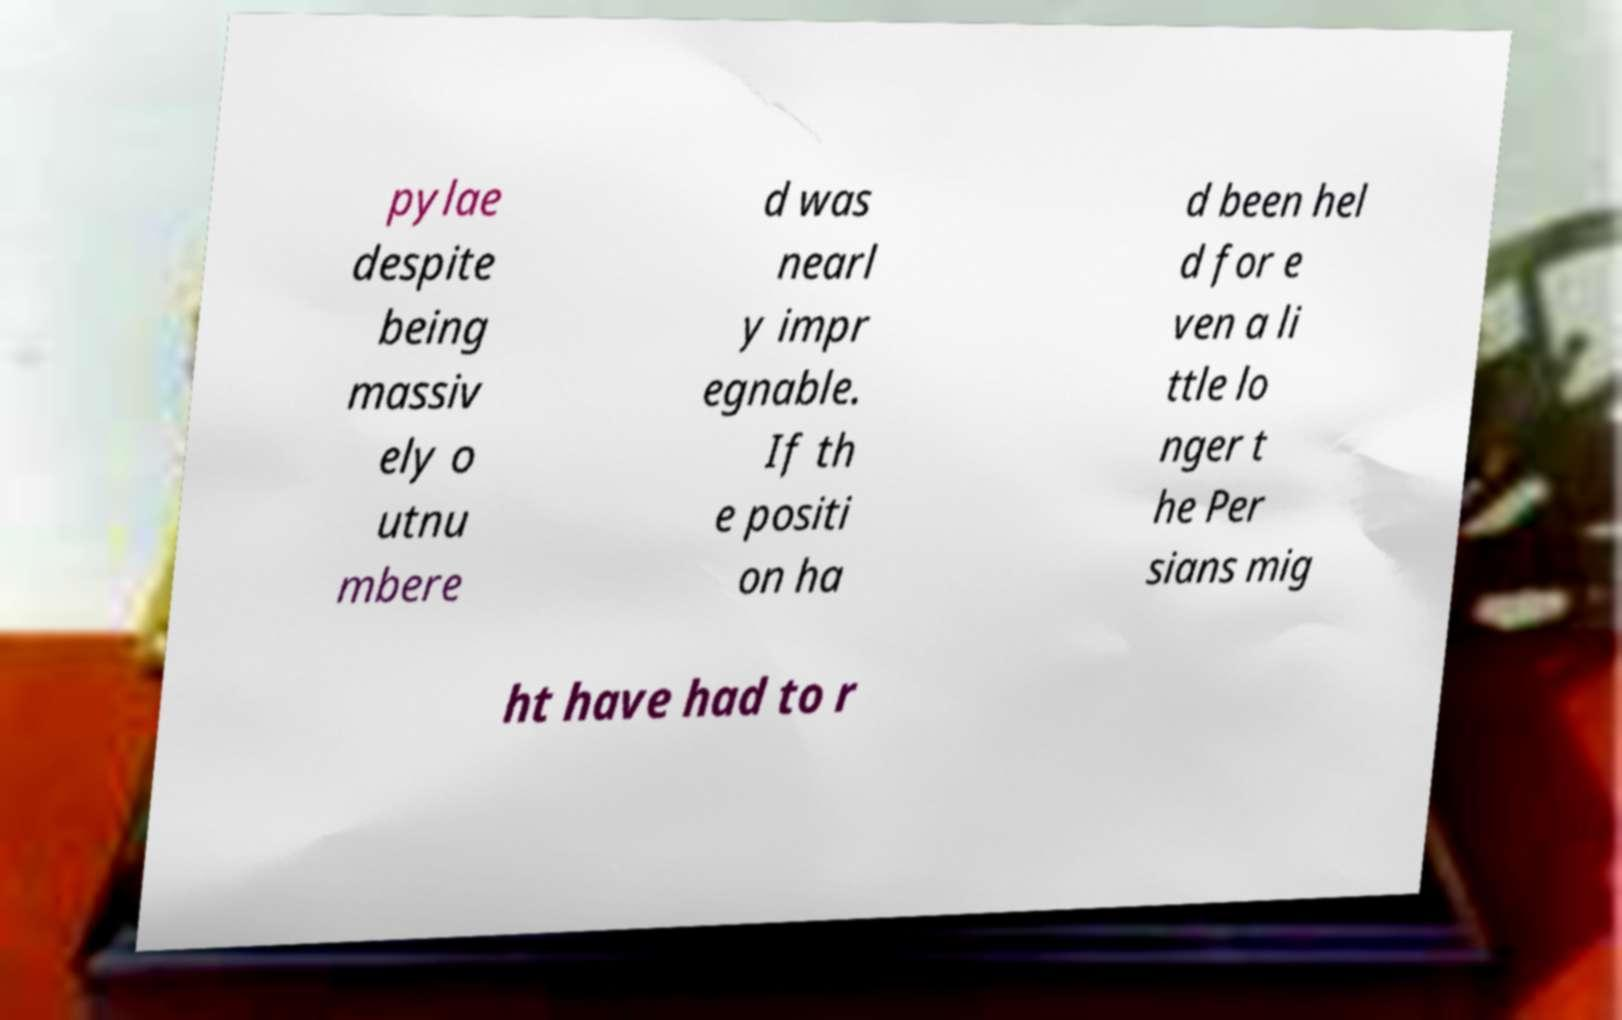There's text embedded in this image that I need extracted. Can you transcribe it verbatim? pylae despite being massiv ely o utnu mbere d was nearl y impr egnable. If th e positi on ha d been hel d for e ven a li ttle lo nger t he Per sians mig ht have had to r 